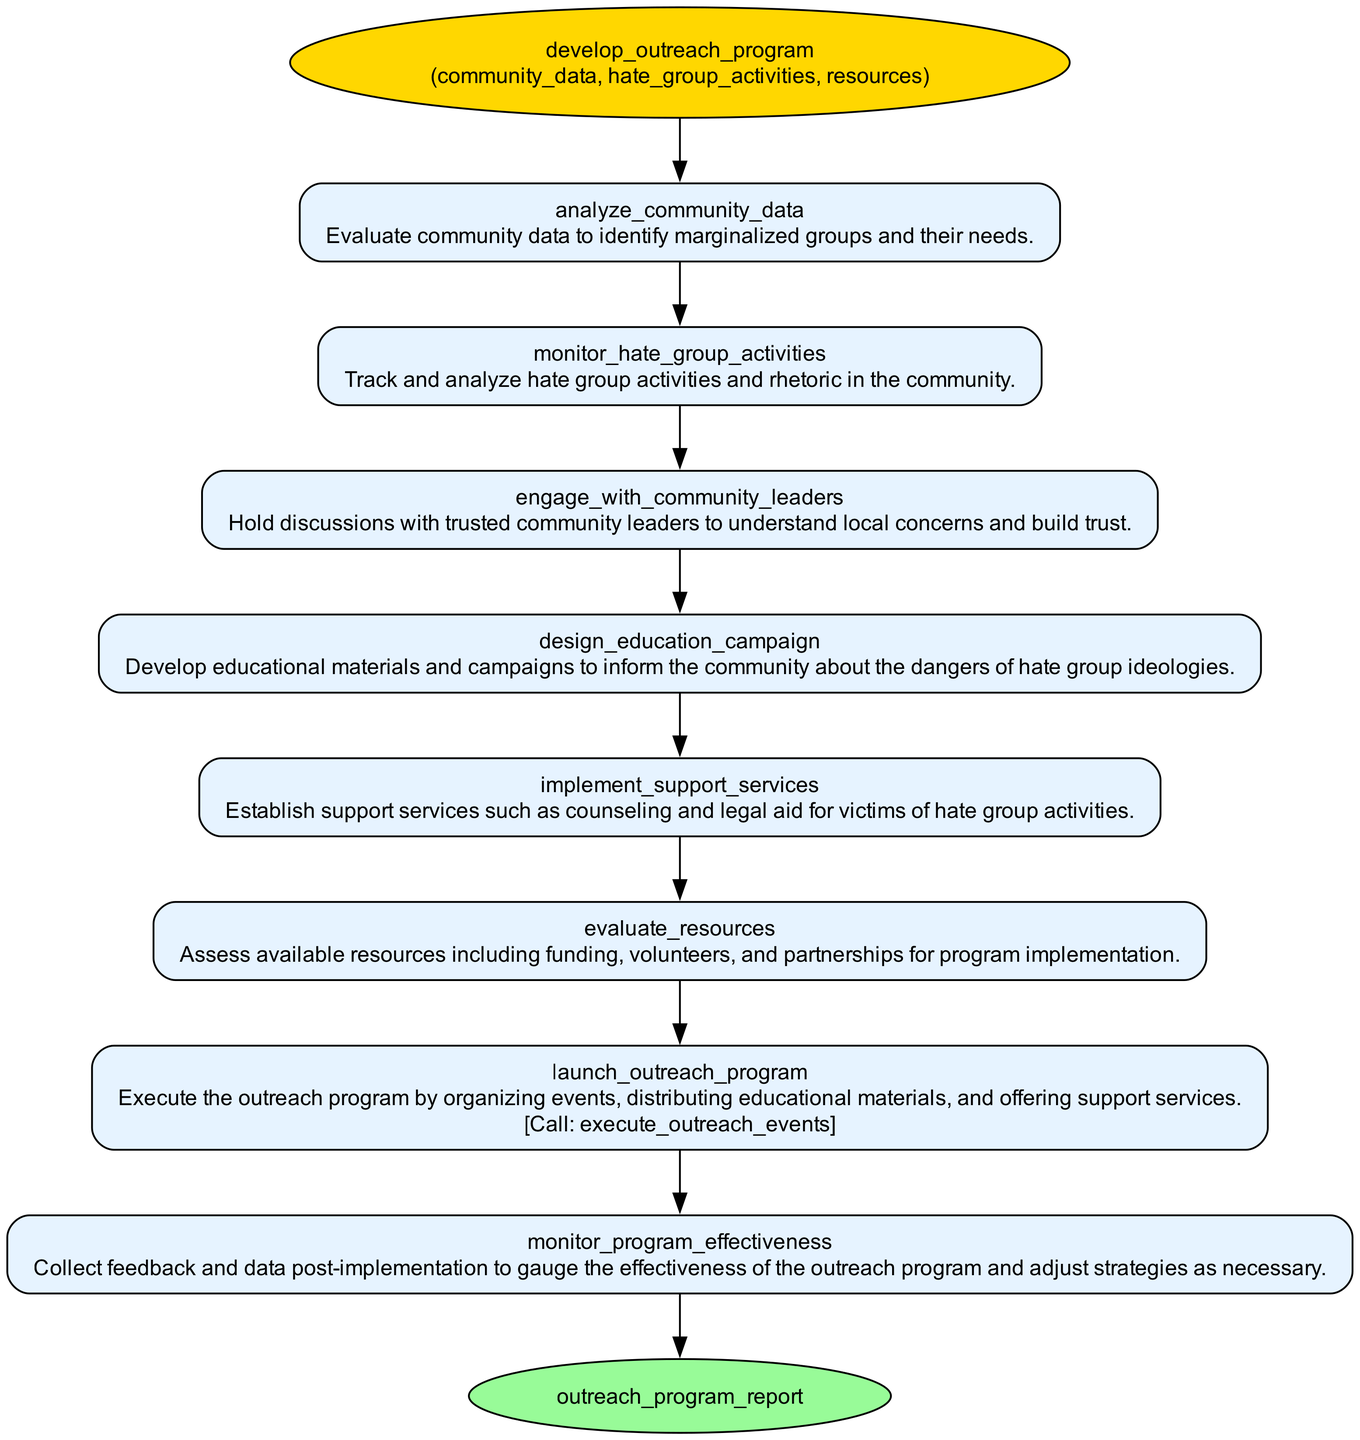What is the function name in this diagram? The function name is explicitly stated at the top of the diagram in an oval-shaped node. It is the title 'develop_outreach_program'.
Answer: develop_outreach_program How many parameters does the function have? The function is defined with three parameters, which are listed in the same node as the function name.
Answer: 3 What is the first step in the outreach program? The first step listed in the ordered flow is 'analyze_community_data', which can be found in the first rectangular node after the function node.
Answer: analyze_community_data What is the last step before launching the outreach program? The step before 'launch_outreach_program' is 'evaluate_resources'. This step assesses available resources.
Answer: evaluate_resources Which step involves collaboration with community leaders? The step that includes collaboration with community leaders is 'engage_with_community_leaders'. It highlights the importance of discussions with trusted leaders.
Answer: engage_with_community_leaders How many steps are followed after analyzing community data? After analyzing community data, there are five additional steps leading to the launch of the outreach program, indicating a sequential flow.
Answer: 5 What type of outputs does the function produce? The process culminates in producing an output, which is described as 'outreach_program_report' in the final node of the flowchart.
Answer: outreach_program_report What is the main purpose of the 'design_education_campaign' step? This step aims to develop educational materials and campaigns to inform the community about the dangers of hate group ideologies, focusing on awareness and prevention.
Answer: Develop educational materials How does the flowchart represent the function's execution? The execution of the outreach program is indicated by a function call noted within the 'launch_outreach_program' step, specifically labeled as 'execute_outreach_events'.
Answer: execute_outreach_events 